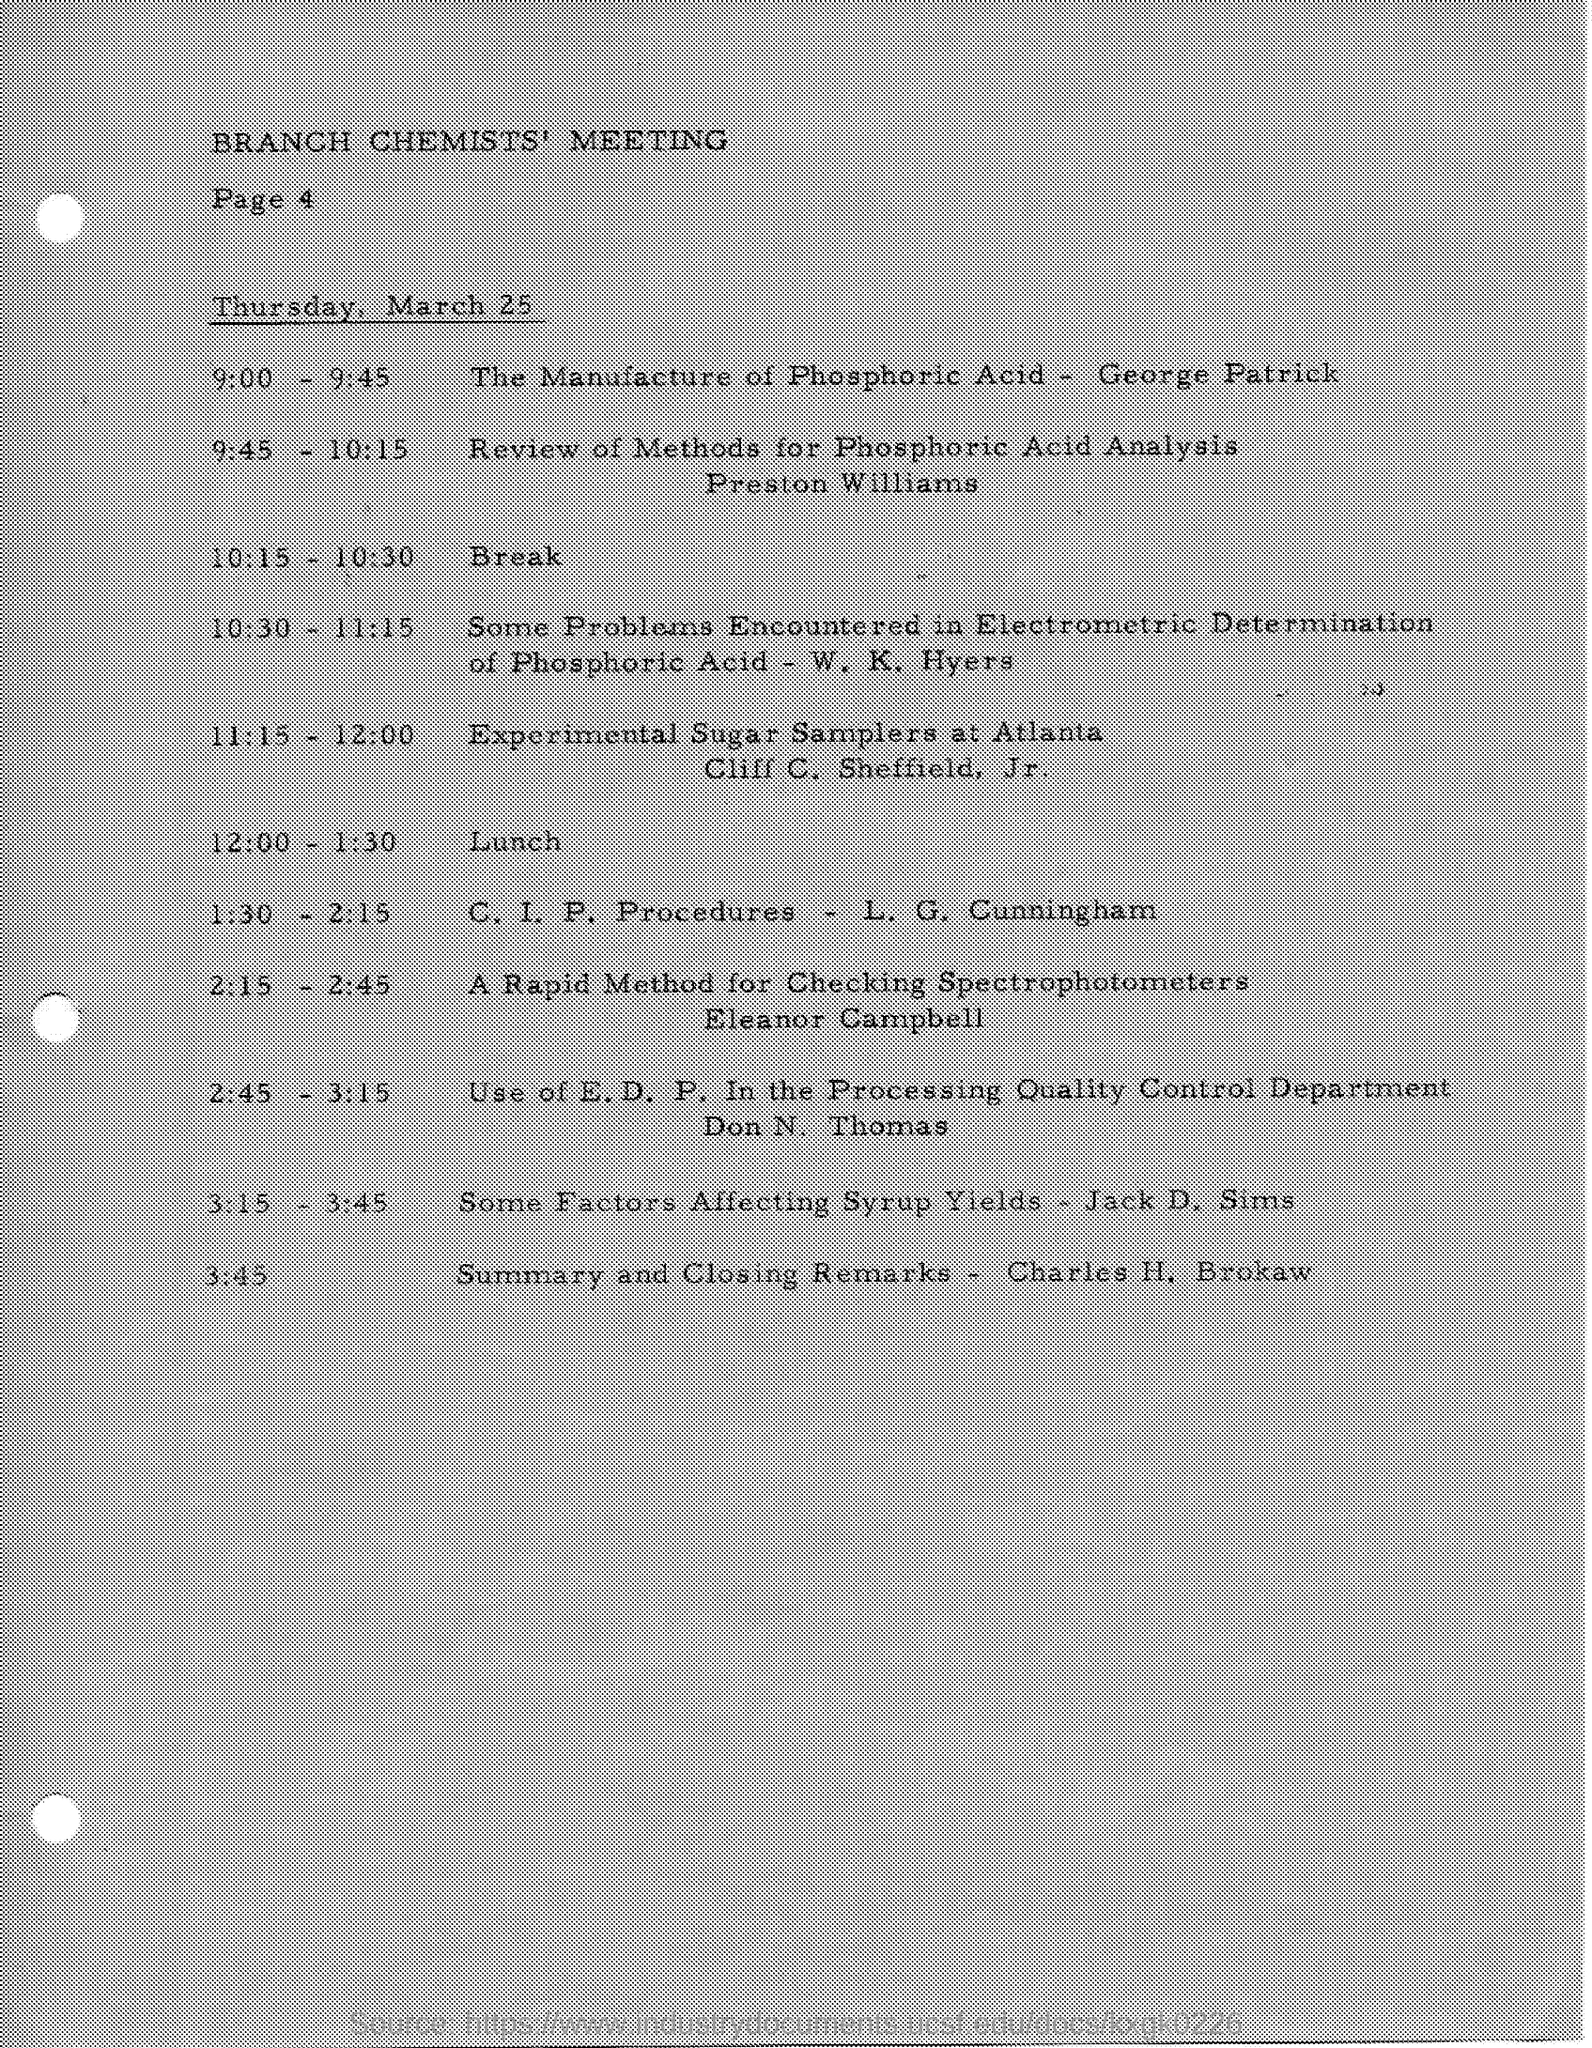Who else presented at the meeting and what were their topics? Other presenters at the Branch Chemists' Meeting included George Patrick on the manufacture of phosphoric acid, W.K. Hyers on electrochemical issues in phosphoric acid, and Eleanor Campbell who discussed methods for checking spectrophotometers, each contributing to a broader understanding of chemical processes and quality control in the industry. 